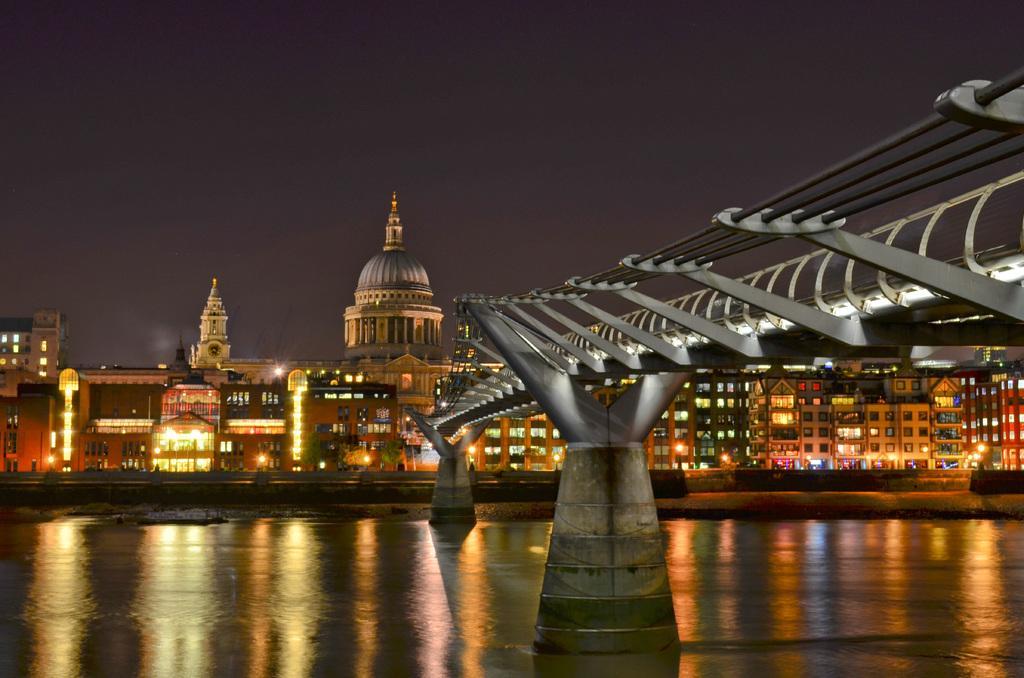Could you give a brief overview of what you see in this image? In this image there is a bridge on the lake, behind that there is a big building with lights on it. 